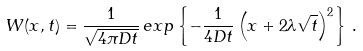Convert formula to latex. <formula><loc_0><loc_0><loc_500><loc_500>W ( x , t ) = \frac { 1 } { \sqrt { 4 \pi D t } } \, e x p \left \{ - \frac { 1 } { 4 D t } \left ( x + 2 \lambda \sqrt { t } \right ) ^ { 2 } \right \} \, .</formula> 